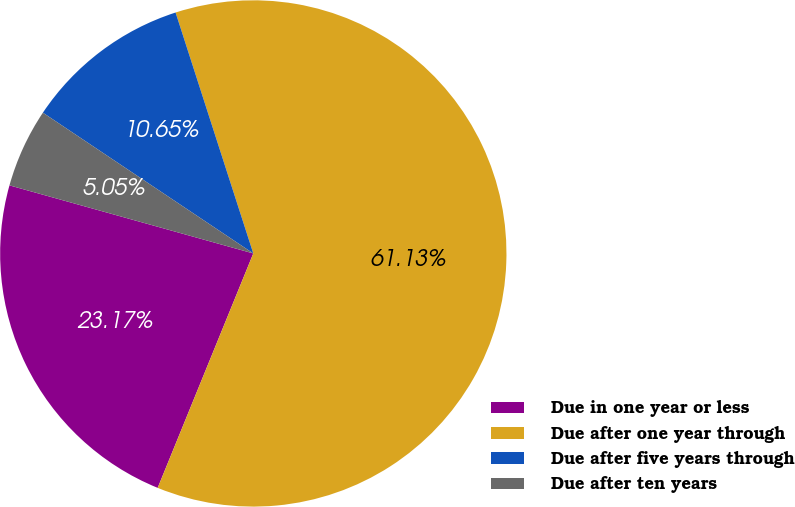Convert chart. <chart><loc_0><loc_0><loc_500><loc_500><pie_chart><fcel>Due in one year or less<fcel>Due after one year through<fcel>Due after five years through<fcel>Due after ten years<nl><fcel>23.17%<fcel>61.13%<fcel>10.65%<fcel>5.05%<nl></chart> 